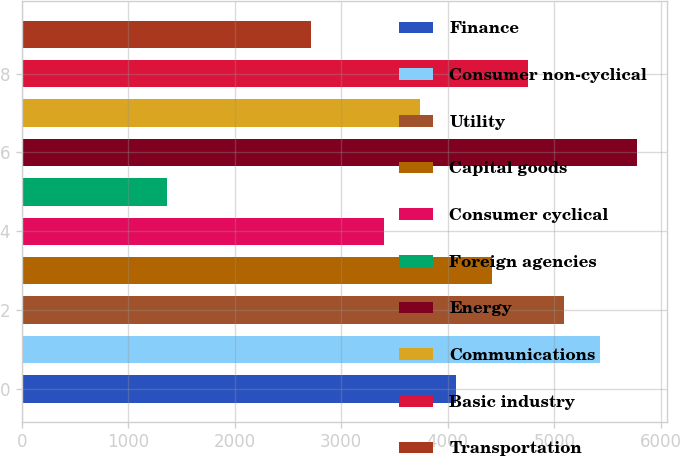Convert chart. <chart><loc_0><loc_0><loc_500><loc_500><bar_chart><fcel>Finance<fcel>Consumer non-cyclical<fcel>Utility<fcel>Capital goods<fcel>Consumer cyclical<fcel>Foreign agencies<fcel>Energy<fcel>Communications<fcel>Basic industry<fcel>Transportation<nl><fcel>4076.4<fcel>5433.2<fcel>5094<fcel>4415.6<fcel>3398<fcel>1362.8<fcel>5772.4<fcel>3737.2<fcel>4754.8<fcel>2719.6<nl></chart> 